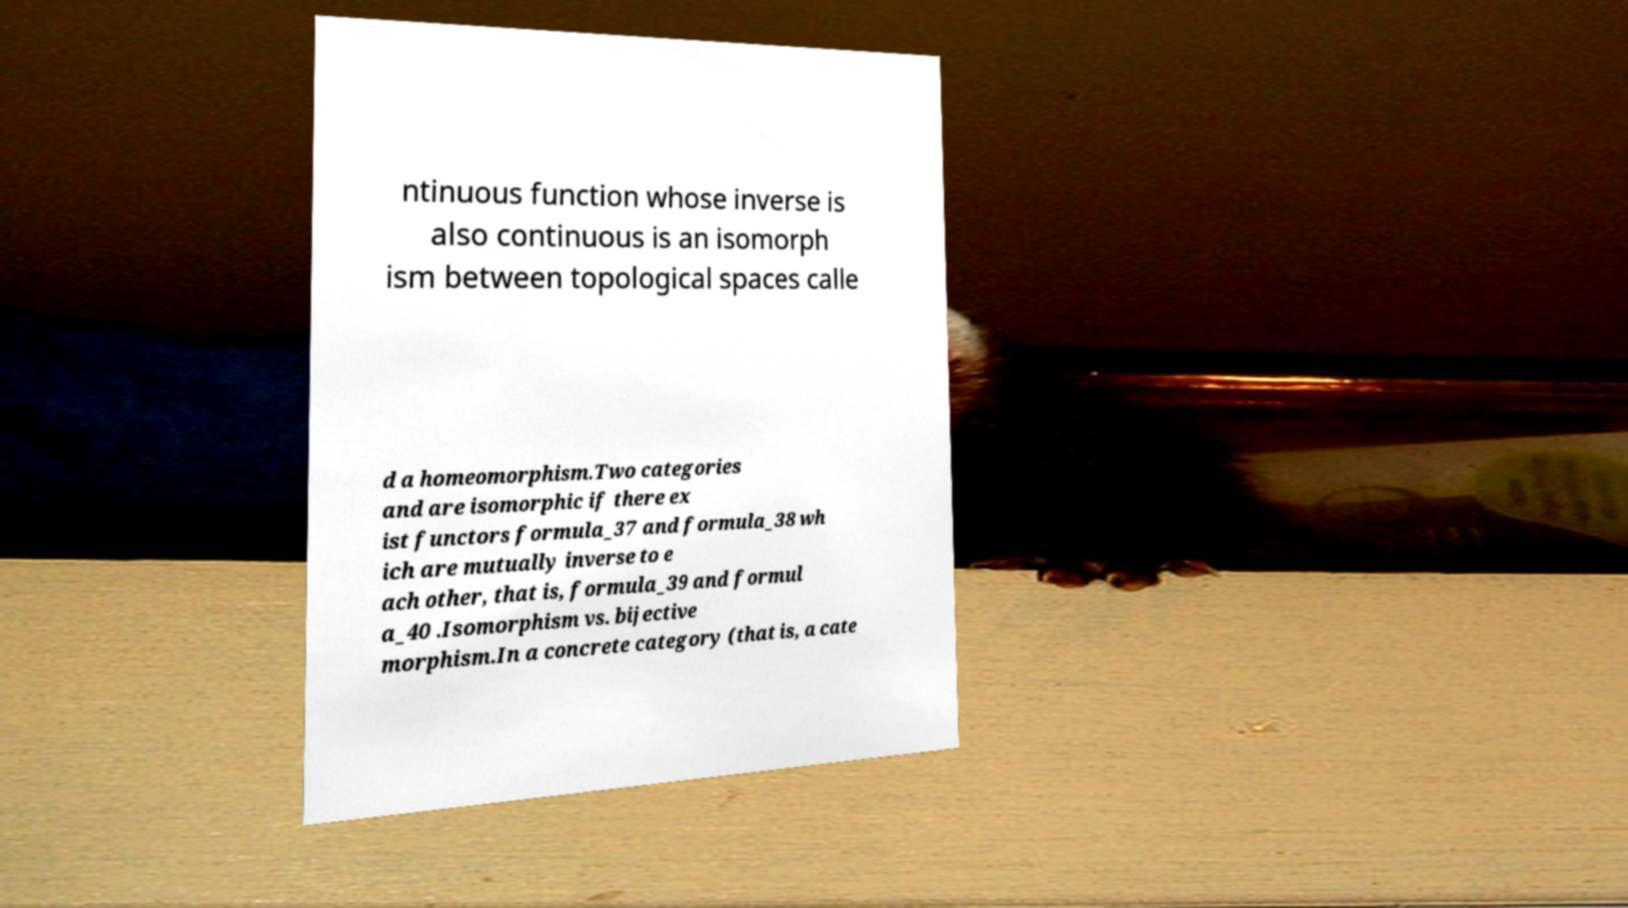Could you assist in decoding the text presented in this image and type it out clearly? ntinuous function whose inverse is also continuous is an isomorph ism between topological spaces calle d a homeomorphism.Two categories and are isomorphic if there ex ist functors formula_37 and formula_38 wh ich are mutually inverse to e ach other, that is, formula_39 and formul a_40 .Isomorphism vs. bijective morphism.In a concrete category (that is, a cate 